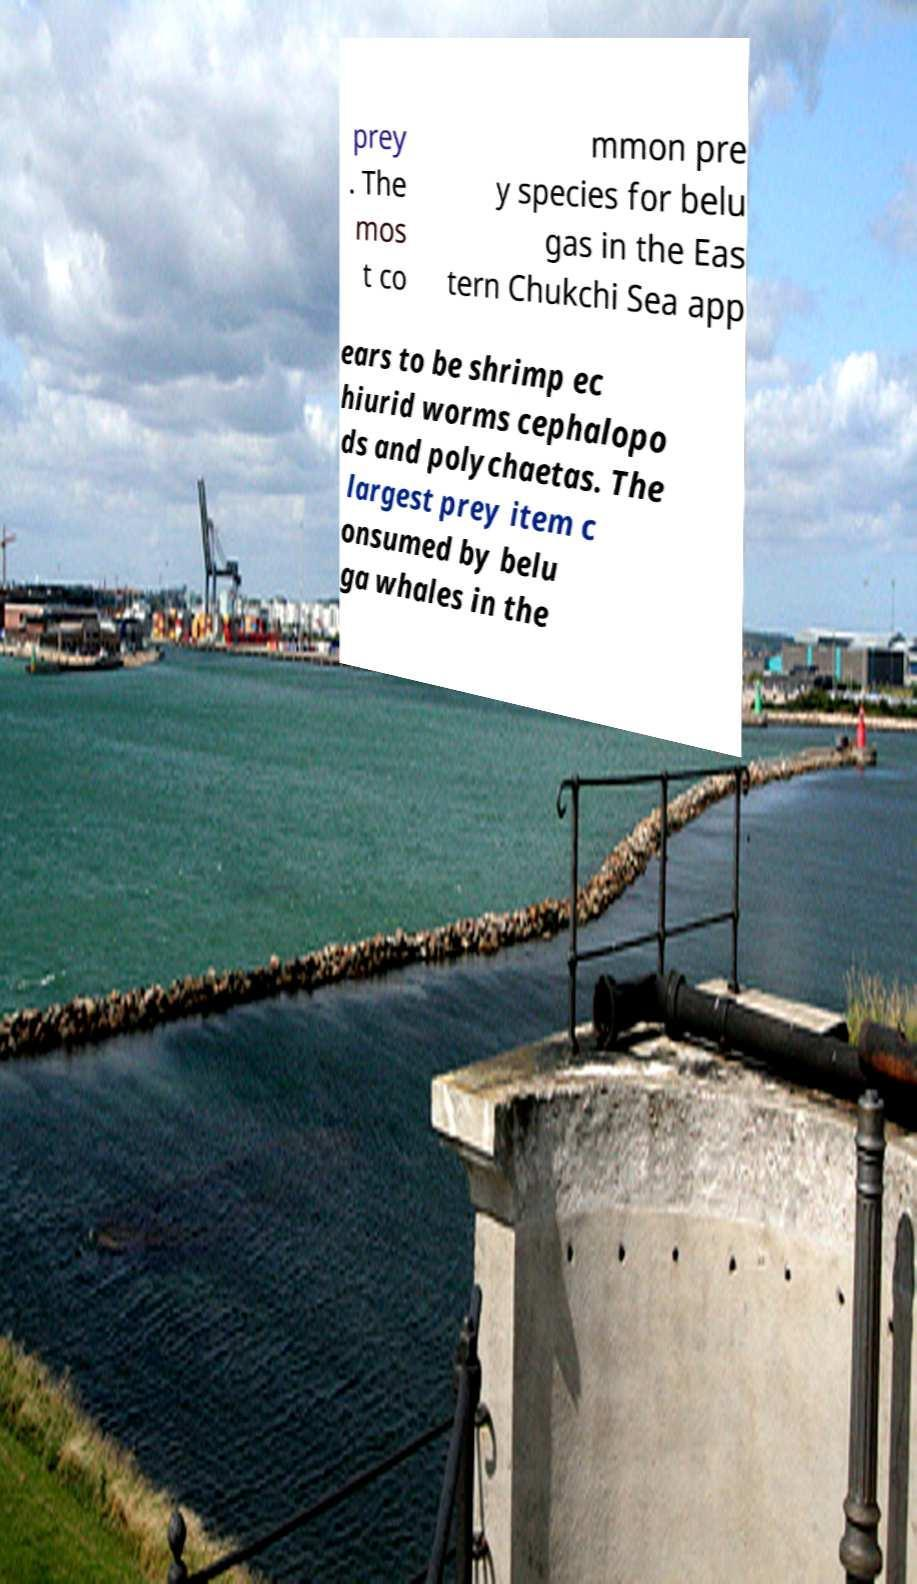What messages or text are displayed in this image? I need them in a readable, typed format. prey . The mos t co mmon pre y species for belu gas in the Eas tern Chukchi Sea app ears to be shrimp ec hiurid worms cephalopo ds and polychaetas. The largest prey item c onsumed by belu ga whales in the 